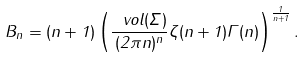Convert formula to latex. <formula><loc_0><loc_0><loc_500><loc_500>B _ { n } = ( n + 1 ) \left ( \frac { \ v o l ( \Sigma ) } { ( 2 \pi n ) ^ { n } } \zeta ( n + 1 ) \Gamma ( n ) \right ) ^ { \frac { 1 } { n + 1 } } .</formula> 